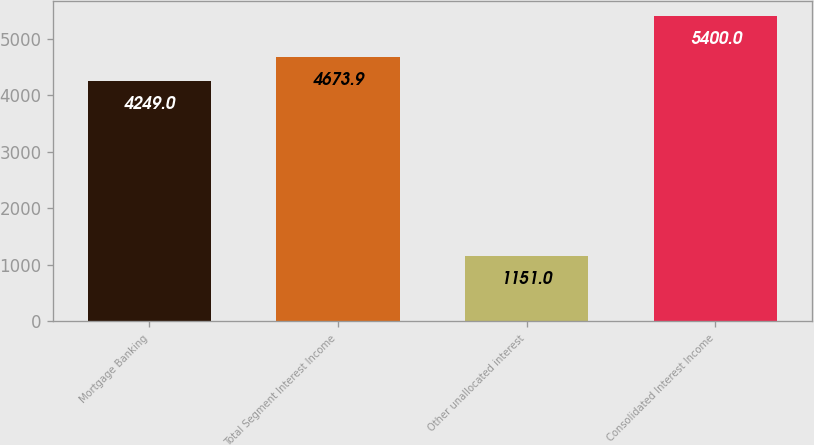Convert chart. <chart><loc_0><loc_0><loc_500><loc_500><bar_chart><fcel>Mortgage Banking<fcel>Total Segment Interest Income<fcel>Other unallocated interest<fcel>Consolidated Interest Income<nl><fcel>4249<fcel>4673.9<fcel>1151<fcel>5400<nl></chart> 